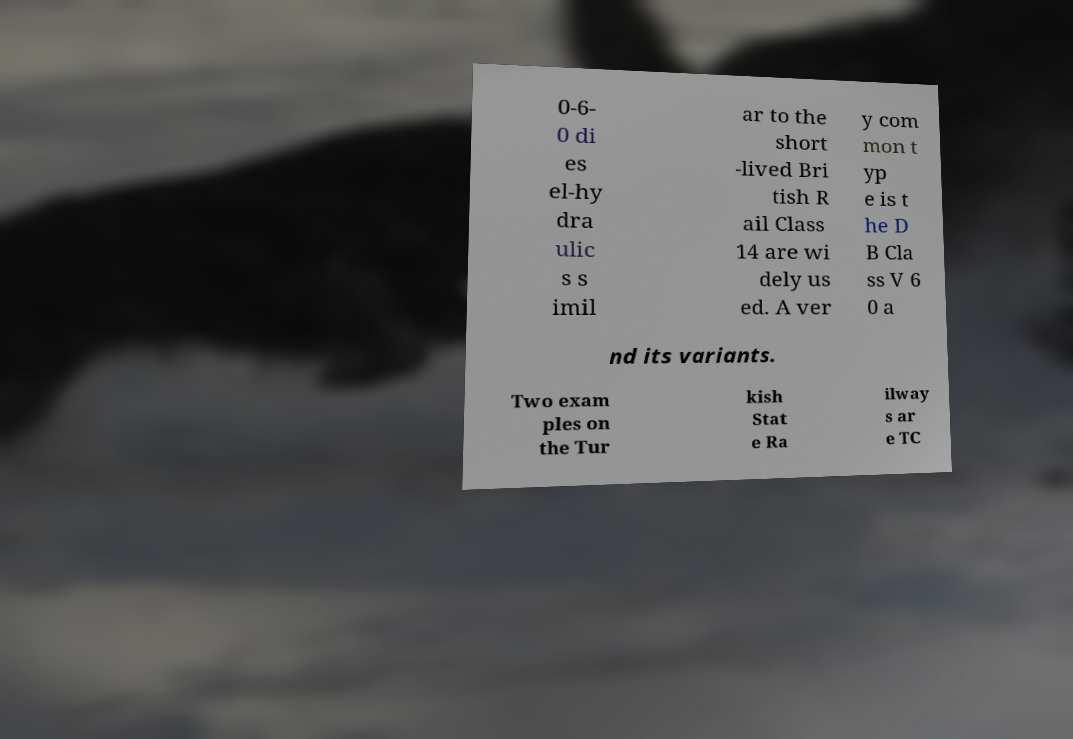There's text embedded in this image that I need extracted. Can you transcribe it verbatim? 0-6- 0 di es el-hy dra ulic s s imil ar to the short -lived Bri tish R ail Class 14 are wi dely us ed. A ver y com mon t yp e is t he D B Cla ss V 6 0 a nd its variants. Two exam ples on the Tur kish Stat e Ra ilway s ar e TC 